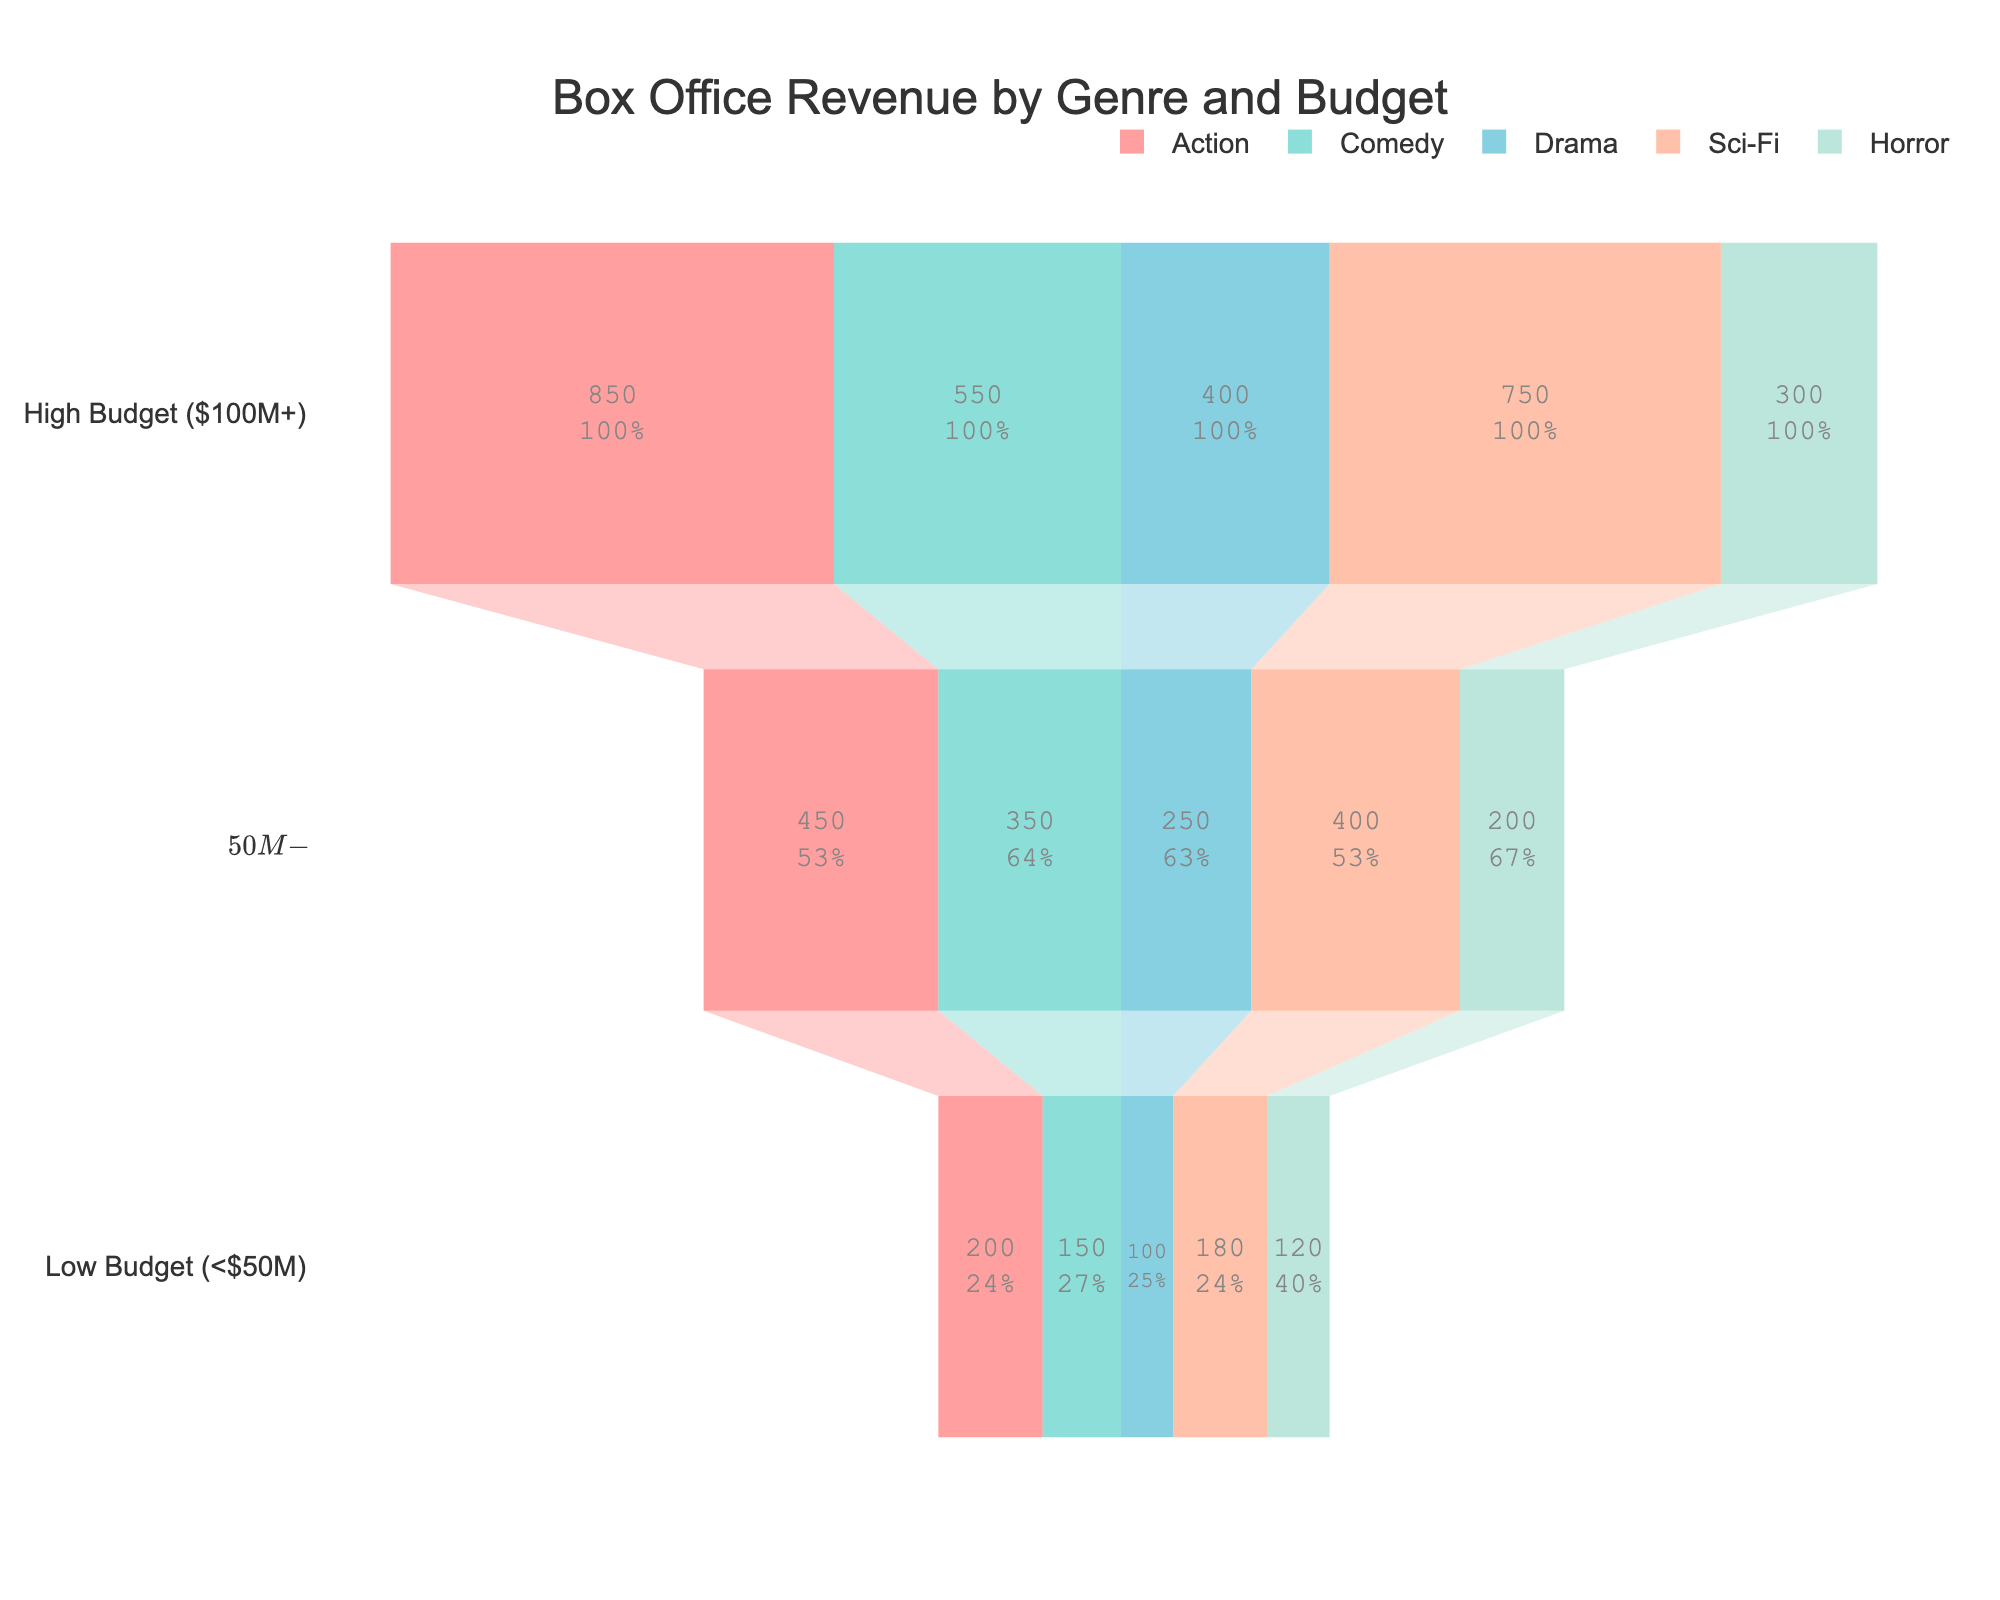What is the title of the chart? The title is located at the top of the chart and reads "Box Office Revenue by Genre and Budget".
Answer: Box Office Revenue by Genre and Budget How many genres are displayed in the funnel chart? There are multiple traces, each representing a genre. By looking at the legend, it is clear that there are five genres displayed.
Answer: Five Which genre has the highest revenue in the High Budget ($100M+) range? Scan the category labels and corresponding bars in the High Budget section. The Action genre has the highest revenue with $850 million.
Answer: Action What is the total revenue for Comedy across all budget ranges? Sum the revenue values for Comedy: High Budget ($100M+), Medium Budget ($50M-$100M), and Low Budget (<$50M): 550 + 350 + 150 = 1050.
Answer: 1050 million Which budget range generates the least revenue for Horror? Inspect the three budget ranges within the Horror genre, looking at the length of the bars. The Low Budget (<$50M) range has the least revenue with $120 million.
Answer: Low Budget (<$50M) Compare the total revenue of the Sci-Fi genre and the Drama genre. Which one is higher? To determine this, sum the revenue values for each genre: Sci-Fi: 750 + 400 + 180 = 1330; Drama: 400 + 250 + 100 = 750. Sci-Fi has a higher total revenue.
Answer: Sci-Fi What percentage of the total High Budget ($100M+) category revenue does the Comedy genre contribute? Calculate the total revenue for the High Budget category: 850 (Action) + 550 (Comedy) + 400 (Drama) + 750 (Sci-Fi) + 300 (Horror) = 2850. Comedy's contribution is 550. The percentage is (550/2850) * 100 ≈ 19.3%.
Answer: 19.3% Is the revenue from Low Budget Action films greater than the revenue from Medium Budget Horror films? Compare the revenues: Low Budget Action films have $200 million, whereas Medium Budget Horror films have $200 million. They are equal.
Answer: No, they are equal Which genre has the smallest range in revenue between its High Budget and Low Budget films? Calculate the difference between High Budget and Low Budget revenue for each genre and find the smallest: Action: 850 - 200 = 650; Comedy: 550 - 150 = 400; Drama: 400 - 100 = 300; Sci-Fi: 750 - 180 = 570; Horror: 300 - 120 = 180. Horror has the smallest range, 180.
Answer: Horror What is the total medium budget revenue across all genres? Sum the medium budget revenue for each genre: Action: 450, Comedy: 350, Drama: 250, Sci-Fi: 400, Horror: 200. Calculating the sum: 450 + 350 + 250 + 400 + 200 = 1650.
Answer: 1650 million 